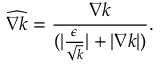Convert formula to latex. <formula><loc_0><loc_0><loc_500><loc_500>\widehat { \nabla k } = \frac { \nabla k } { ( | \frac { \epsilon } { \sqrt { k } } | + | \nabla k | ) } .</formula> 